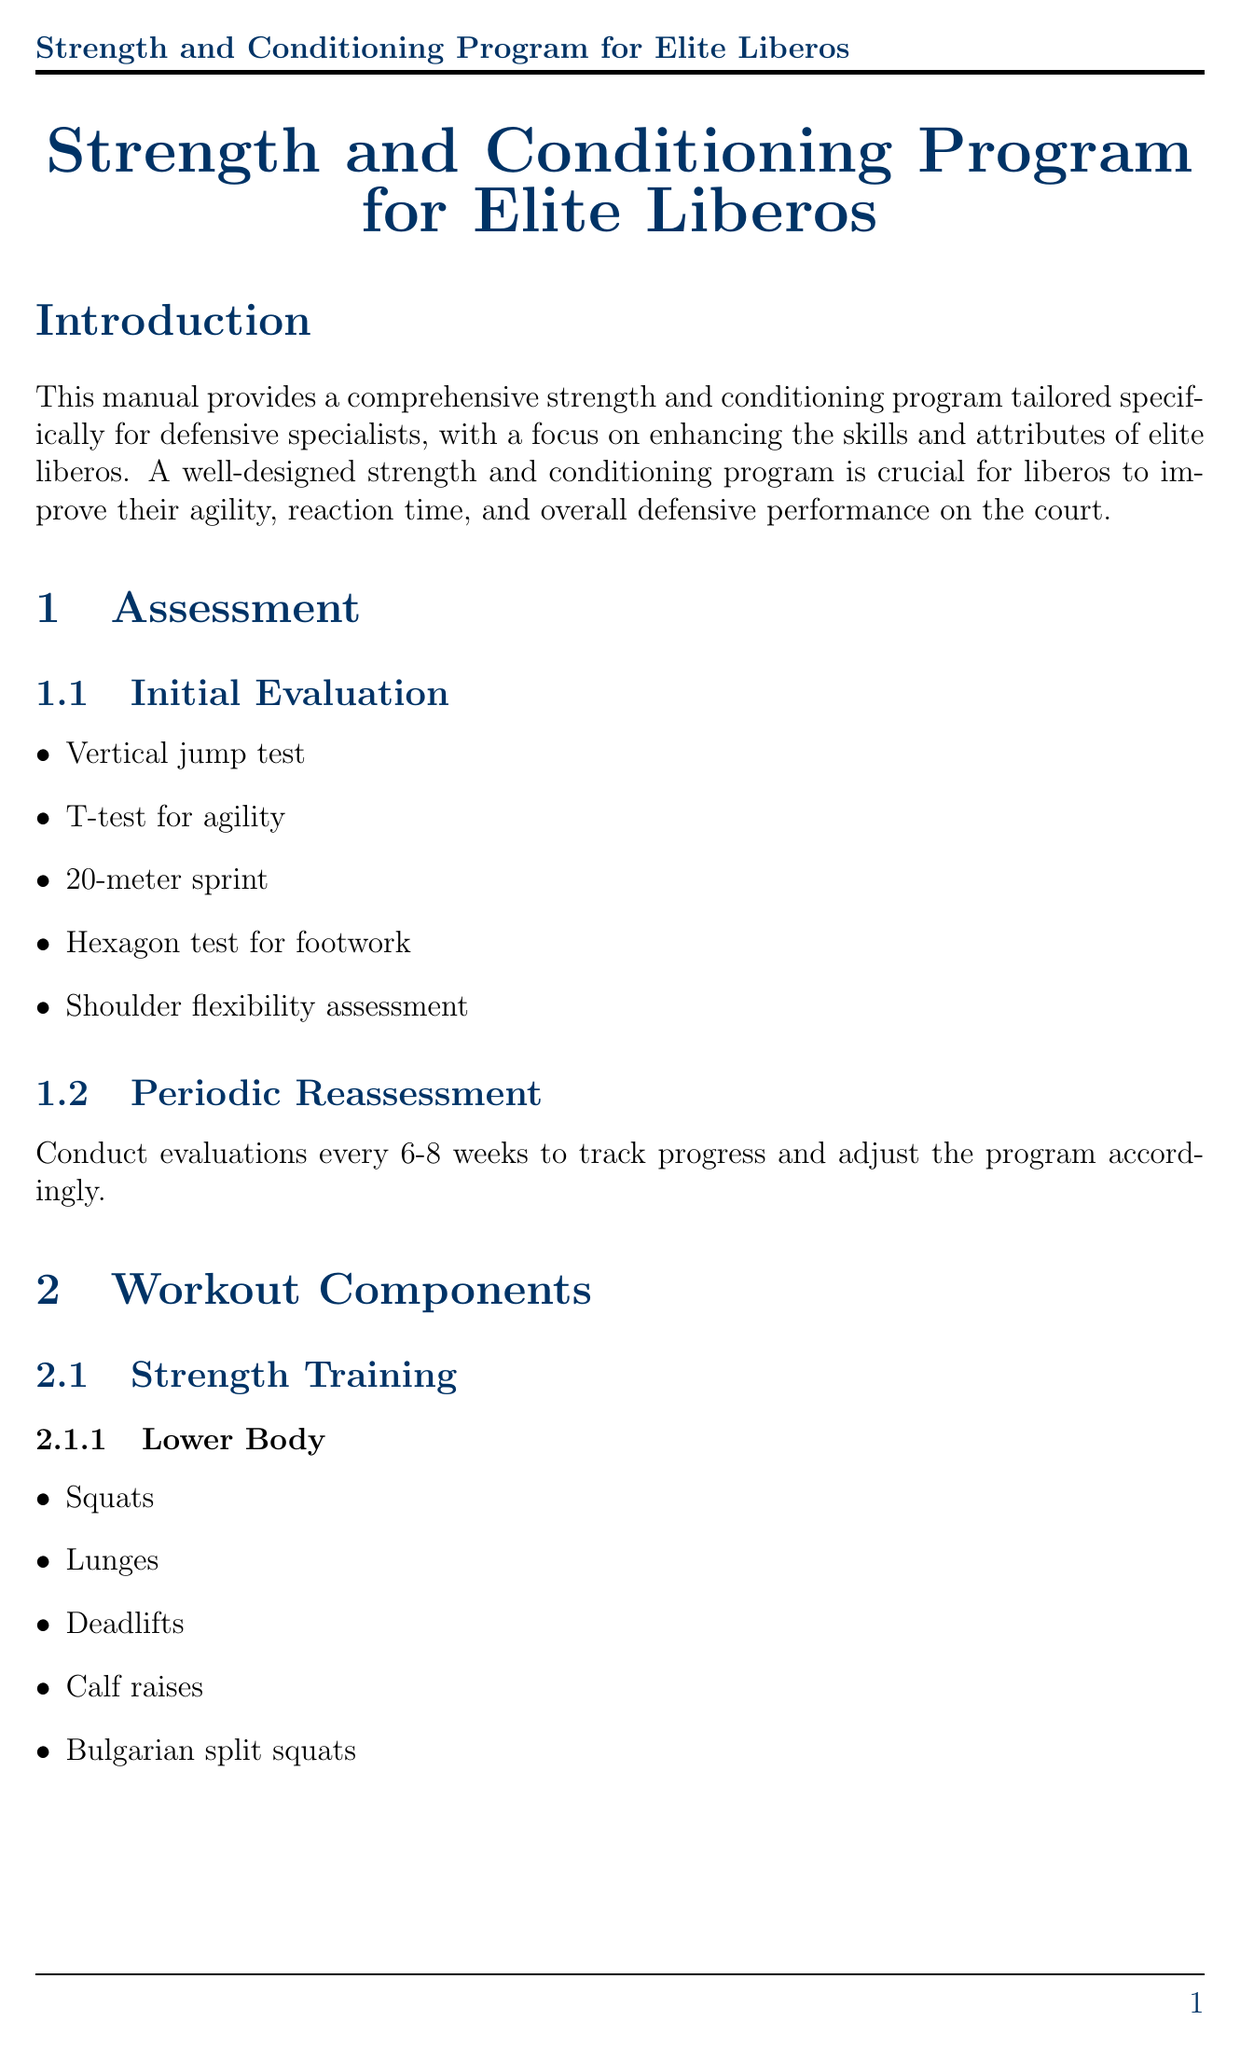What is the title of the manual? The title of the manual is presented in the document header section.
Answer: Strength and Conditioning Program for Elite Liberos How often should periodic reassessments be conducted? The document specifies a time frame for periodic reassessments under the assessment section.
Answer: Every 6-8 weeks What are the core strength training exercises? The exercises for core strength training are listed in the workout components section.
Answer: Planks, Russian twists, Medicine ball rotations, Cable woodchoppers, Stability ball rollouts What is the recommended macronutrient balance? The nutrition guidelines section provides specific ratios for macronutrient balance.
Answer: 50% carbohydrates, 25% protein, 25% healthy fats Which day is designated for active recovery? The sample weekly schedule indicates the day assigned for active recovery activities.
Answer: Wednesday What injury is mentioned as a common injury? Common injuries are listed under the injury prevention section of the document.
Answer: Ankle sprains What visualization technique is suggested for mental preparation? The mental preparation section contains techniques to enhance performance focus.
Answer: Visualize successful defensive plays and perfect passing form What type of tools can be used for performance tracking? The performance tracking section outlines tools for monitoring performance stats.
Answer: Volleyball statistics software, Video analysis of game performance, Wearable technology for tracking physical output 